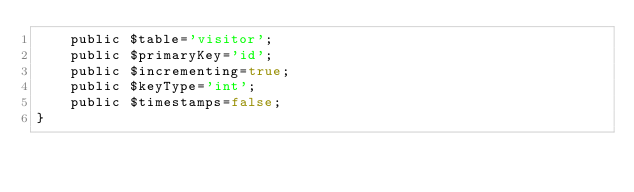Convert code to text. <code><loc_0><loc_0><loc_500><loc_500><_PHP_>    public $table='visitor';
    public $primaryKey='id';
    public $incrementing=true;
    public $keyType='int';
    public $timestamps=false;
}
</code> 